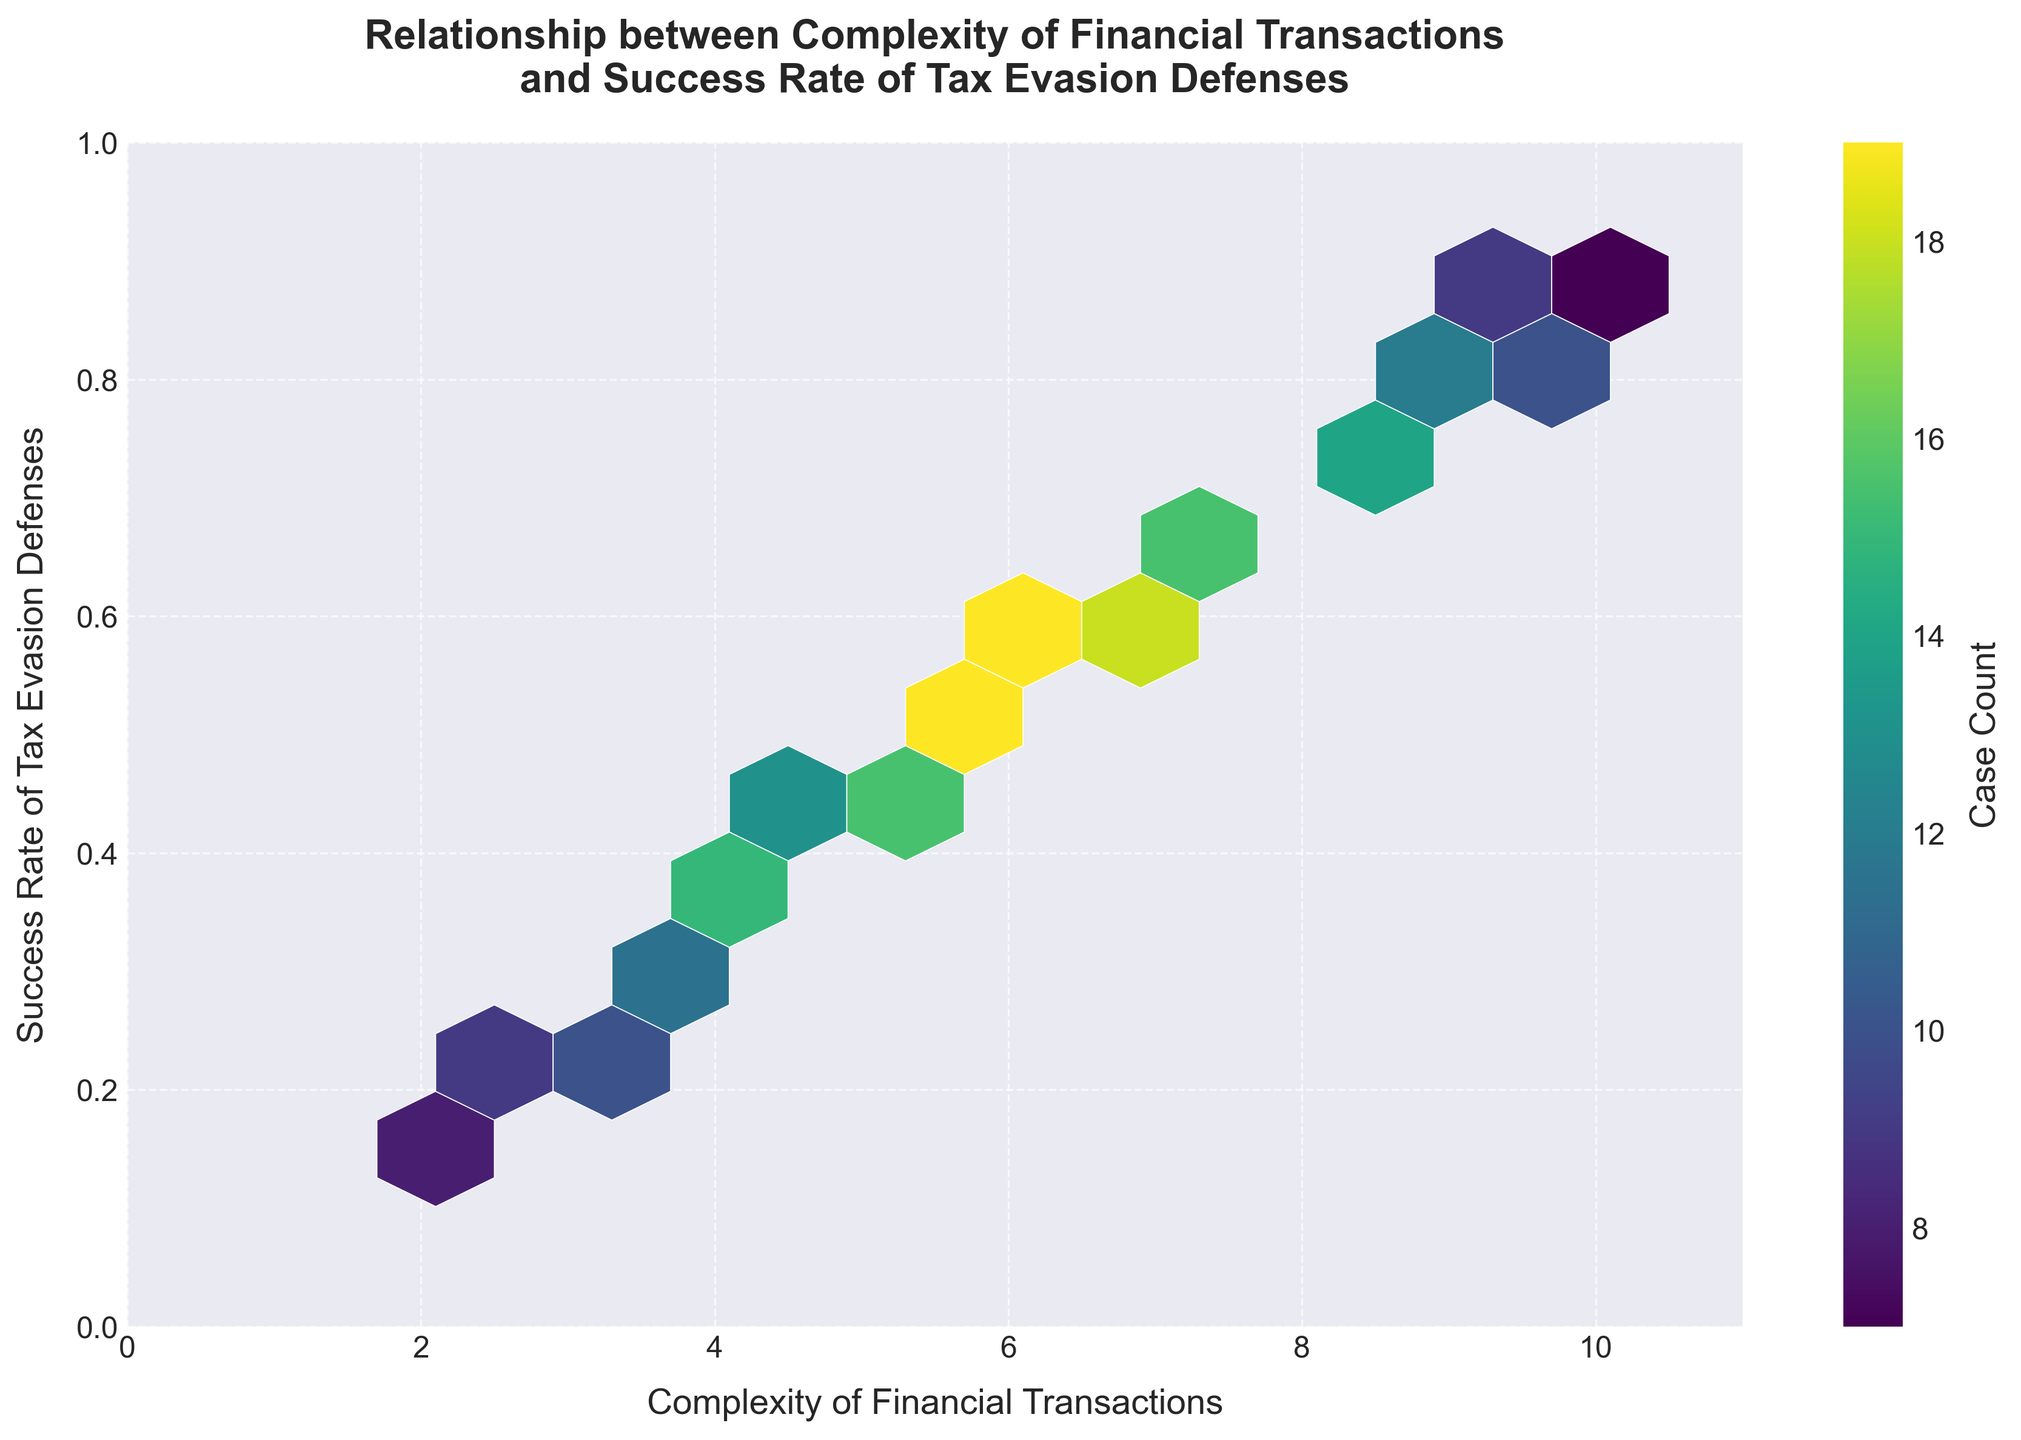What is the title of the hexbin plot? The title of the plot is clearly displayed at the top in bold text. It reads "Relationship between Complexity of Financial Transactions and Success Rate of Tax Evasion Defenses".
Answer: Relationship between Complexity of Financial Transactions and Success Rate of Tax Evasion Defenses What are the labels for the x-axis and y-axis? The x-axis is labeled "Complexity of Financial Transactions" and the y-axis is labeled "Success Rate of Tax Evasion Defenses". These labels are placed below the respective axes and are visible in the plot.
Answer: Complexity of Financial Transactions; Success Rate of Tax Evasion Defenses Which hexbin has the highest case count? The color intensity on the hexbin plot represents the case count. The hexbin located at the coordinates where the Complexity is around 6.3 and the Success Rate is around 0.58 is the most intense, indicating the highest case count.
Answer: Hexbin at Complexity ~6.3 and Success Rate ~0.58 How does the success rate of tax evasion defenses change as the complexity of financial transactions increases? Observing the hexbin plot, as the complexity of financial transactions increases along the x-axis, the success rate of tax evasion defenses also increases along the y-axis, which is evident from the trend of the hexes moving upward as they move right.
Answer: Increases What is the range of values for the x-axis (Complexity)? The x-axis in the hexbin plot is labeled from 0 to 11, indicating that the range of Complexity values is from 0 to 11.
Answer: 0 to 11 Compare the case count for hexes near the Complexity value of 3.5 and a Success Rate of approximately 0.28 with those near the Complexity value of 7.5 and a Success Rate of approximately 0.68. Which has more case counts? The hexbin plot shows that the hex at Complexity of 3.5 and Success Rate of 0.28 has less color intensity compared to the hex at Complexity of 7.5 and Success Rate of 0.68. This indicates more case counts for the latter hex.
Answer: Hex at Complexity 7.5 and Success Rate 0.68 What is the overall trend between Complexity and Success Rate observed in this plot? By examining the general distribution of hexes, it is apparent that there is a positive correlation between Complexity and Success Rate, where higher complexity values tend to align with higher success rates in tax evasion defenses.
Answer: Positive correlation How many grid cells (hexagons) are there in total on the hexbin plot? The hexbin plot uses a grid size of 10, creating a total of 100 hexagonal bins across the plot area as the plot is divided into a 10x10 grid of hexes.
Answer: 100 What does the color of the hexes represent in this plot? The color of the hexes, as indicated by the color bar on the side, represents the case count, with a more intense color indicating a higher count of cases.
Answer: Case Count 